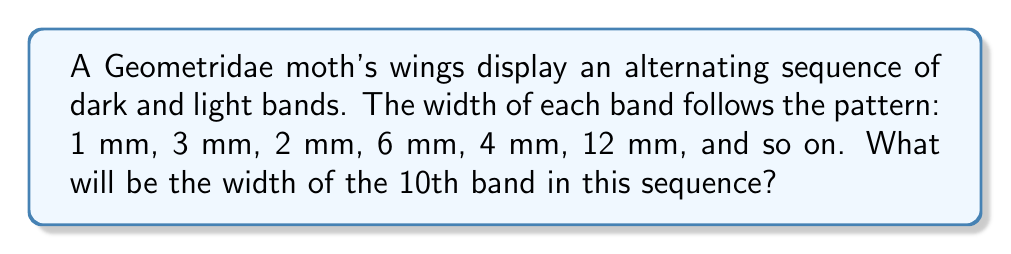Help me with this question. Let's approach this step-by-step:

1) First, let's identify the pattern in the sequence:
   1, 3, 2, 6, 4, 12, ...

2) We can split this into two sub-sequences:
   Odd terms:  1, 2, 4, ...
   Even terms: 3, 6, 12, ...

3) For the odd terms:
   $a_n = 2^{n-1}$ where n is the position in the odd sub-sequence

4) For the even terms:
   $b_n = 3 \cdot 2^{n-1}$ where n is the position in the even sub-sequence

5) We can combine these into a single formula:
   $c_n = \begin{cases} 
   2^{\frac{n+1}{2}-1} & \text{if n is odd} \\
   3 \cdot 2^{\frac{n}{2}-1} & \text{if n is even}
   \end{cases}$

6) We're asked for the 10th term, which is even. So we use the second case:
   $c_{10} = 3 \cdot 2^{\frac{10}{2}-1} = 3 \cdot 2^4 = 3 \cdot 16 = 48$

Therefore, the width of the 10th band will be 48 mm.
Answer: 48 mm 